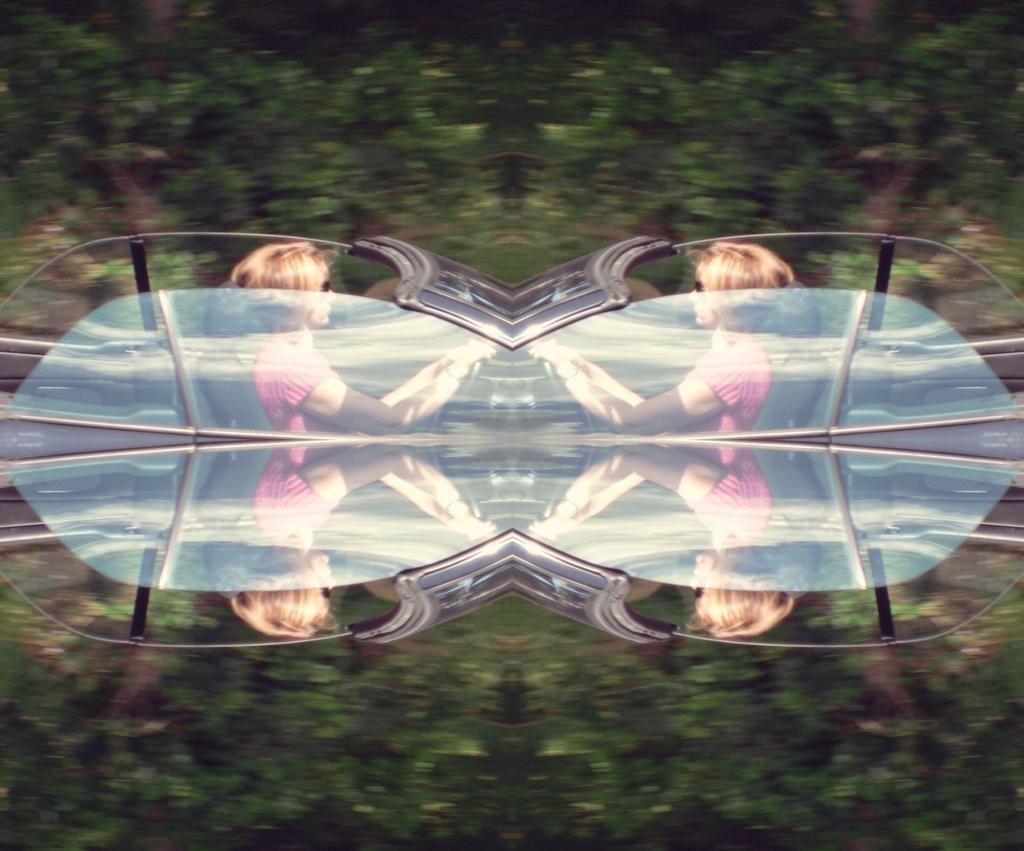In one or two sentences, can you explain what this image depicts? In this image we can see an edited image of a woman looks like driving a car and a blurry background. 